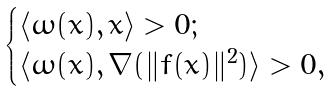Convert formula to latex. <formula><loc_0><loc_0><loc_500><loc_500>\begin{cases} \langle \omega ( x ) , x \rangle > 0 ; \\ \langle \omega ( x ) , \nabla ( \| f ( x ) \| ^ { 2 } ) \rangle > 0 , \end{cases}</formula> 